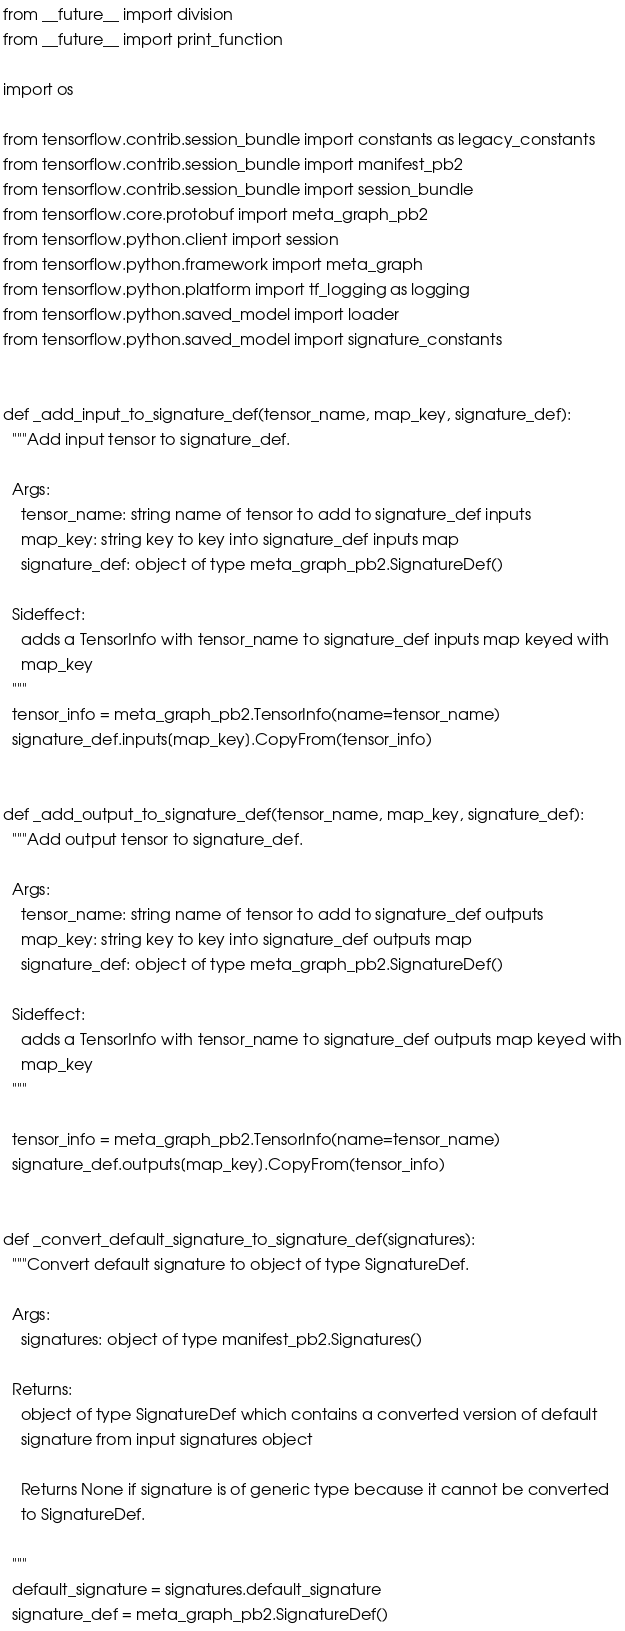<code> <loc_0><loc_0><loc_500><loc_500><_Python_>from __future__ import division
from __future__ import print_function

import os

from tensorflow.contrib.session_bundle import constants as legacy_constants
from tensorflow.contrib.session_bundle import manifest_pb2
from tensorflow.contrib.session_bundle import session_bundle
from tensorflow.core.protobuf import meta_graph_pb2
from tensorflow.python.client import session
from tensorflow.python.framework import meta_graph
from tensorflow.python.platform import tf_logging as logging
from tensorflow.python.saved_model import loader
from tensorflow.python.saved_model import signature_constants


def _add_input_to_signature_def(tensor_name, map_key, signature_def):
  """Add input tensor to signature_def.

  Args:
    tensor_name: string name of tensor to add to signature_def inputs
    map_key: string key to key into signature_def inputs map
    signature_def: object of type meta_graph_pb2.SignatureDef()

  Sideffect:
    adds a TensorInfo with tensor_name to signature_def inputs map keyed with
    map_key
  """
  tensor_info = meta_graph_pb2.TensorInfo(name=tensor_name)
  signature_def.inputs[map_key].CopyFrom(tensor_info)


def _add_output_to_signature_def(tensor_name, map_key, signature_def):
  """Add output tensor to signature_def.

  Args:
    tensor_name: string name of tensor to add to signature_def outputs
    map_key: string key to key into signature_def outputs map
    signature_def: object of type meta_graph_pb2.SignatureDef()

  Sideffect:
    adds a TensorInfo with tensor_name to signature_def outputs map keyed with
    map_key
  """

  tensor_info = meta_graph_pb2.TensorInfo(name=tensor_name)
  signature_def.outputs[map_key].CopyFrom(tensor_info)


def _convert_default_signature_to_signature_def(signatures):
  """Convert default signature to object of type SignatureDef.

  Args:
    signatures: object of type manifest_pb2.Signatures()

  Returns:
    object of type SignatureDef which contains a converted version of default
    signature from input signatures object

    Returns None if signature is of generic type because it cannot be converted
    to SignatureDef.

  """
  default_signature = signatures.default_signature
  signature_def = meta_graph_pb2.SignatureDef()</code> 